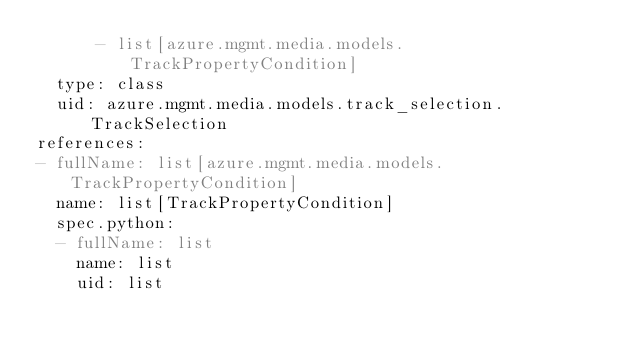<code> <loc_0><loc_0><loc_500><loc_500><_YAML_>      - list[azure.mgmt.media.models.TrackPropertyCondition]
  type: class
  uid: azure.mgmt.media.models.track_selection.TrackSelection
references:
- fullName: list[azure.mgmt.media.models.TrackPropertyCondition]
  name: list[TrackPropertyCondition]
  spec.python:
  - fullName: list
    name: list
    uid: list</code> 